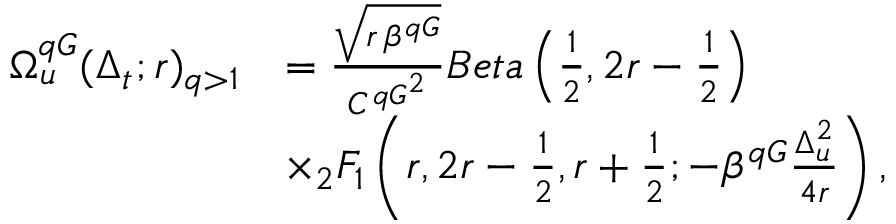<formula> <loc_0><loc_0><loc_500><loc_500>\begin{array} { r l } { \Omega _ { u } ^ { q G } ( \Delta _ { t } ; r ) _ { q > 1 } } & { = \frac { \sqrt { r \, \beta ^ { q G } } } { { C ^ { q G } } ^ { 2 } } B e t a \left ( \frac { 1 } { 2 } , 2 r - \frac { 1 } { 2 } \right ) } \\ & { \times _ { 2 } F _ { 1 } \left ( r , 2 r - \frac { 1 } { 2 } , r + \frac { 1 } { 2 } ; - \beta ^ { q G } \frac { \Delta _ { u } ^ { 2 } } { 4 r } \right ) , } \end{array}</formula> 